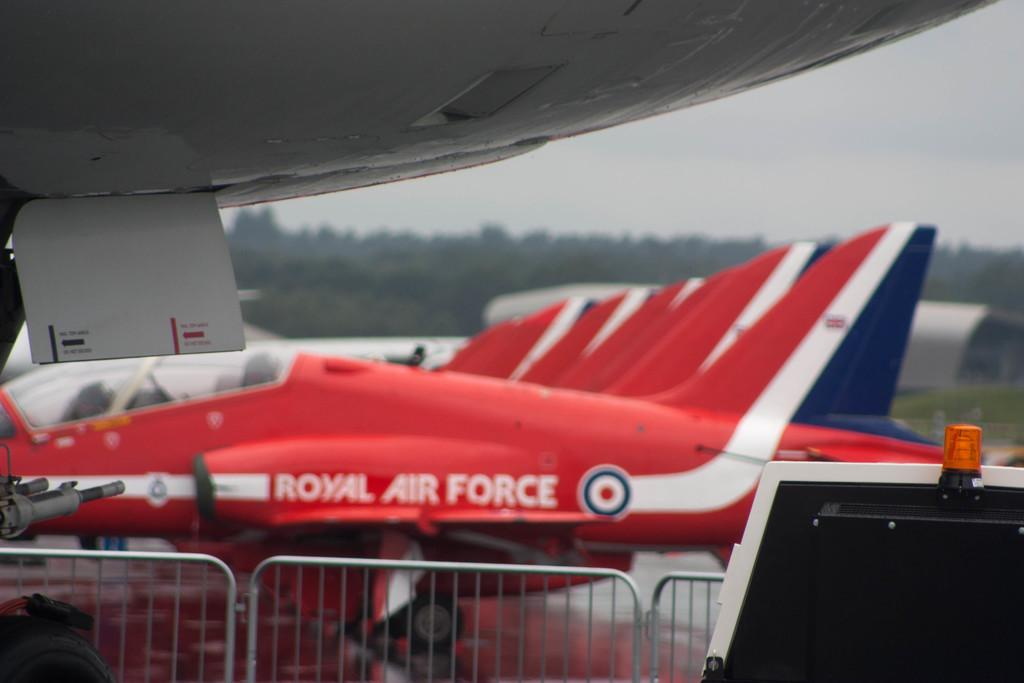<image>
Relay a brief, clear account of the picture shown. A red white and blue jet with the words Royal Air Force written on the side 